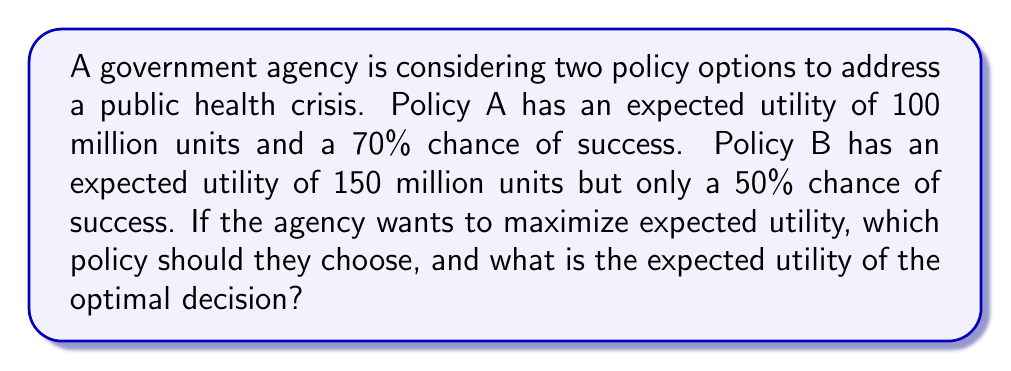Could you help me with this problem? To solve this problem, we need to calculate the expected utility for each policy option and compare them. The expected utility is calculated by multiplying the utility value by the probability of success.

For Policy A:
$$ EU_A = 100 \text{ million} \times 0.70 = 70 \text{ million units} $$

For Policy B:
$$ EU_B = 150 \text{ million} \times 0.50 = 75 \text{ million units} $$

To maximize expected utility, we choose the policy with the higher expected utility value. In this case, Policy B has a higher expected utility (75 million units) compared to Policy A (70 million units).

The expected utility of the optimal decision is therefore 75 million units.

This problem demonstrates the application of game theory and expected utility maximization in public policy decision-making. By quantifying the potential outcomes and their probabilities, policymakers can make more informed decisions that optimize the expected benefits to society.
Answer: The agency should choose Policy B, and the expected utility of the optimal decision is 75 million units. 